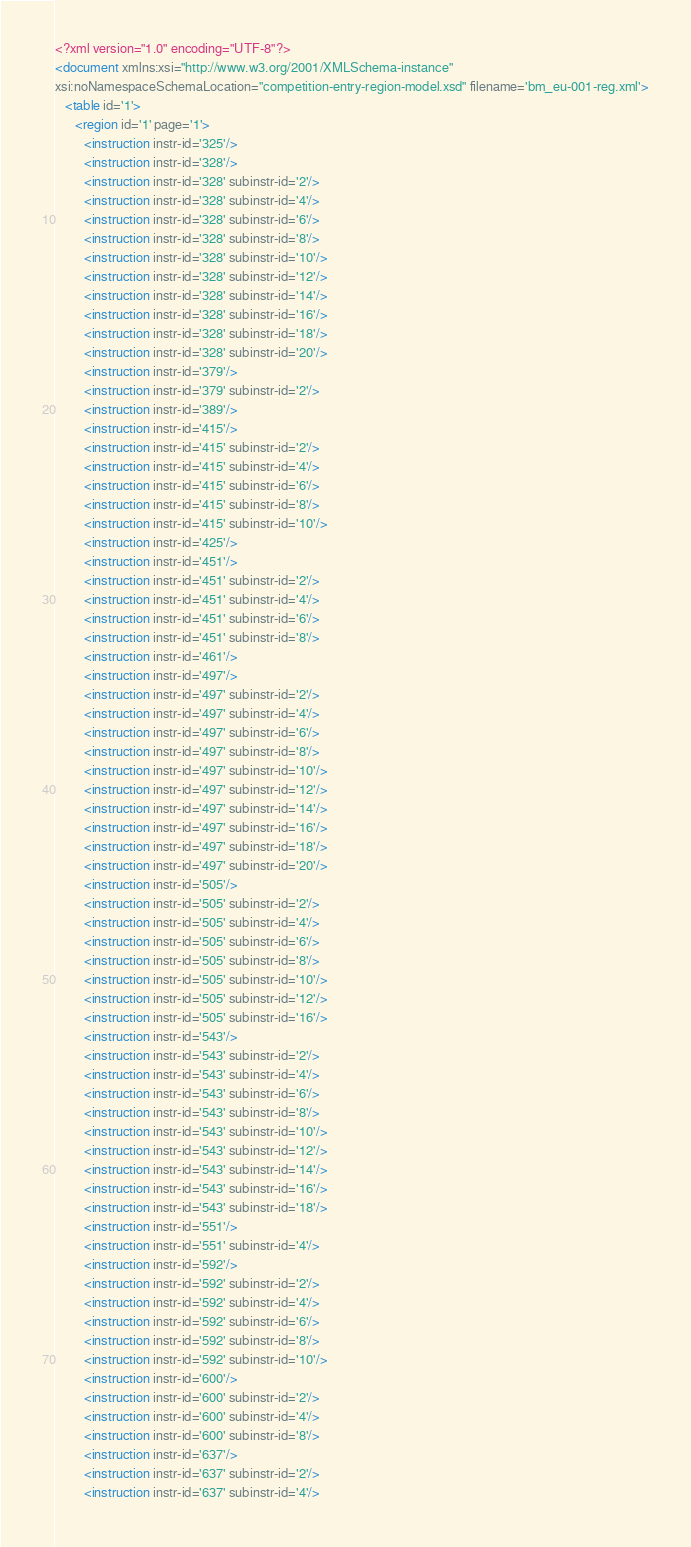<code> <loc_0><loc_0><loc_500><loc_500><_XML_><?xml version="1.0" encoding="UTF-8"?>
<document xmlns:xsi="http://www.w3.org/2001/XMLSchema-instance"
xsi:noNamespaceSchemaLocation="competition-entry-region-model.xsd" filename='bm_eu-001-reg.xml'>
   <table id='1'>
      <region id='1' page='1'>
         <instruction instr-id='325'/>
         <instruction instr-id='328'/>
         <instruction instr-id='328' subinstr-id='2'/>
         <instruction instr-id='328' subinstr-id='4'/>
         <instruction instr-id='328' subinstr-id='6'/>
         <instruction instr-id='328' subinstr-id='8'/>
         <instruction instr-id='328' subinstr-id='10'/>
         <instruction instr-id='328' subinstr-id='12'/>
         <instruction instr-id='328' subinstr-id='14'/>
         <instruction instr-id='328' subinstr-id='16'/>
         <instruction instr-id='328' subinstr-id='18'/>
         <instruction instr-id='328' subinstr-id='20'/>
         <instruction instr-id='379'/>
         <instruction instr-id='379' subinstr-id='2'/>
         <instruction instr-id='389'/>
         <instruction instr-id='415'/>
         <instruction instr-id='415' subinstr-id='2'/>
         <instruction instr-id='415' subinstr-id='4'/>
         <instruction instr-id='415' subinstr-id='6'/>
         <instruction instr-id='415' subinstr-id='8'/>
         <instruction instr-id='415' subinstr-id='10'/>
         <instruction instr-id='425'/>
         <instruction instr-id='451'/>
         <instruction instr-id='451' subinstr-id='2'/>
         <instruction instr-id='451' subinstr-id='4'/>
         <instruction instr-id='451' subinstr-id='6'/>
         <instruction instr-id='451' subinstr-id='8'/>
         <instruction instr-id='461'/>
         <instruction instr-id='497'/>
         <instruction instr-id='497' subinstr-id='2'/>
         <instruction instr-id='497' subinstr-id='4'/>
         <instruction instr-id='497' subinstr-id='6'/>
         <instruction instr-id='497' subinstr-id='8'/>
         <instruction instr-id='497' subinstr-id='10'/>
         <instruction instr-id='497' subinstr-id='12'/>
         <instruction instr-id='497' subinstr-id='14'/>
         <instruction instr-id='497' subinstr-id='16'/>
         <instruction instr-id='497' subinstr-id='18'/>
         <instruction instr-id='497' subinstr-id='20'/>
         <instruction instr-id='505'/>
         <instruction instr-id='505' subinstr-id='2'/>
         <instruction instr-id='505' subinstr-id='4'/>
         <instruction instr-id='505' subinstr-id='6'/>
         <instruction instr-id='505' subinstr-id='8'/>
         <instruction instr-id='505' subinstr-id='10'/>
         <instruction instr-id='505' subinstr-id='12'/>
         <instruction instr-id='505' subinstr-id='16'/>
         <instruction instr-id='543'/>
         <instruction instr-id='543' subinstr-id='2'/>
         <instruction instr-id='543' subinstr-id='4'/>
         <instruction instr-id='543' subinstr-id='6'/>
         <instruction instr-id='543' subinstr-id='8'/>
         <instruction instr-id='543' subinstr-id='10'/>
         <instruction instr-id='543' subinstr-id='12'/>
         <instruction instr-id='543' subinstr-id='14'/>
         <instruction instr-id='543' subinstr-id='16'/>
         <instruction instr-id='543' subinstr-id='18'/>
         <instruction instr-id='551'/>
         <instruction instr-id='551' subinstr-id='4'/>
         <instruction instr-id='592'/>
         <instruction instr-id='592' subinstr-id='2'/>
         <instruction instr-id='592' subinstr-id='4'/>
         <instruction instr-id='592' subinstr-id='6'/>
         <instruction instr-id='592' subinstr-id='8'/>
         <instruction instr-id='592' subinstr-id='10'/>
         <instruction instr-id='600'/>
         <instruction instr-id='600' subinstr-id='2'/>
         <instruction instr-id='600' subinstr-id='4'/>
         <instruction instr-id='600' subinstr-id='8'/>
         <instruction instr-id='637'/>
         <instruction instr-id='637' subinstr-id='2'/>
         <instruction instr-id='637' subinstr-id='4'/></code> 